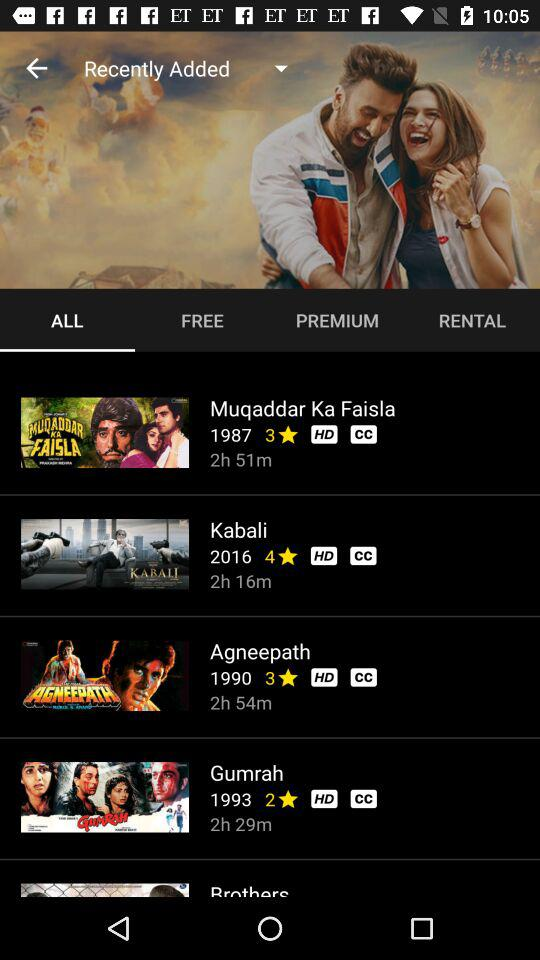What is the duration of the movie "Muqaddar Ka Faisla"? The duration of the movie "Muqaddar Ka Faisla" is 2 hours 51 minutes. 